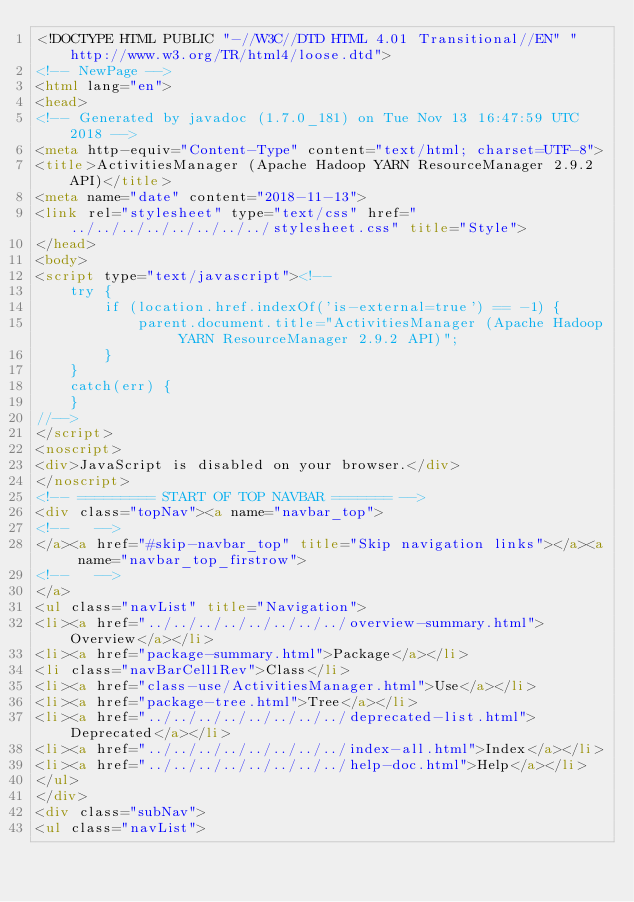<code> <loc_0><loc_0><loc_500><loc_500><_HTML_><!DOCTYPE HTML PUBLIC "-//W3C//DTD HTML 4.01 Transitional//EN" "http://www.w3.org/TR/html4/loose.dtd">
<!-- NewPage -->
<html lang="en">
<head>
<!-- Generated by javadoc (1.7.0_181) on Tue Nov 13 16:47:59 UTC 2018 -->
<meta http-equiv="Content-Type" content="text/html; charset=UTF-8">
<title>ActivitiesManager (Apache Hadoop YARN ResourceManager 2.9.2 API)</title>
<meta name="date" content="2018-11-13">
<link rel="stylesheet" type="text/css" href="../../../../../../../../stylesheet.css" title="Style">
</head>
<body>
<script type="text/javascript"><!--
    try {
        if (location.href.indexOf('is-external=true') == -1) {
            parent.document.title="ActivitiesManager (Apache Hadoop YARN ResourceManager 2.9.2 API)";
        }
    }
    catch(err) {
    }
//-->
</script>
<noscript>
<div>JavaScript is disabled on your browser.</div>
</noscript>
<!-- ========= START OF TOP NAVBAR ======= -->
<div class="topNav"><a name="navbar_top">
<!--   -->
</a><a href="#skip-navbar_top" title="Skip navigation links"></a><a name="navbar_top_firstrow">
<!--   -->
</a>
<ul class="navList" title="Navigation">
<li><a href="../../../../../../../../overview-summary.html">Overview</a></li>
<li><a href="package-summary.html">Package</a></li>
<li class="navBarCell1Rev">Class</li>
<li><a href="class-use/ActivitiesManager.html">Use</a></li>
<li><a href="package-tree.html">Tree</a></li>
<li><a href="../../../../../../../../deprecated-list.html">Deprecated</a></li>
<li><a href="../../../../../../../../index-all.html">Index</a></li>
<li><a href="../../../../../../../../help-doc.html">Help</a></li>
</ul>
</div>
<div class="subNav">
<ul class="navList"></code> 